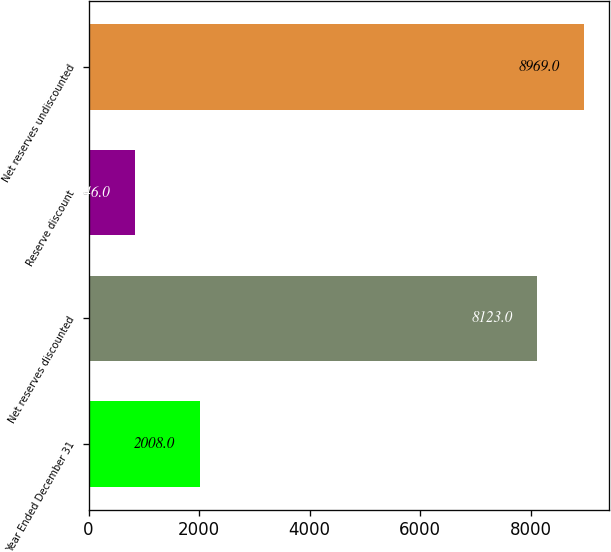Convert chart. <chart><loc_0><loc_0><loc_500><loc_500><bar_chart><fcel>Year Ended December 31<fcel>Net reserves discounted<fcel>Reserve discount<fcel>Net reserves undiscounted<nl><fcel>2008<fcel>8123<fcel>846<fcel>8969<nl></chart> 